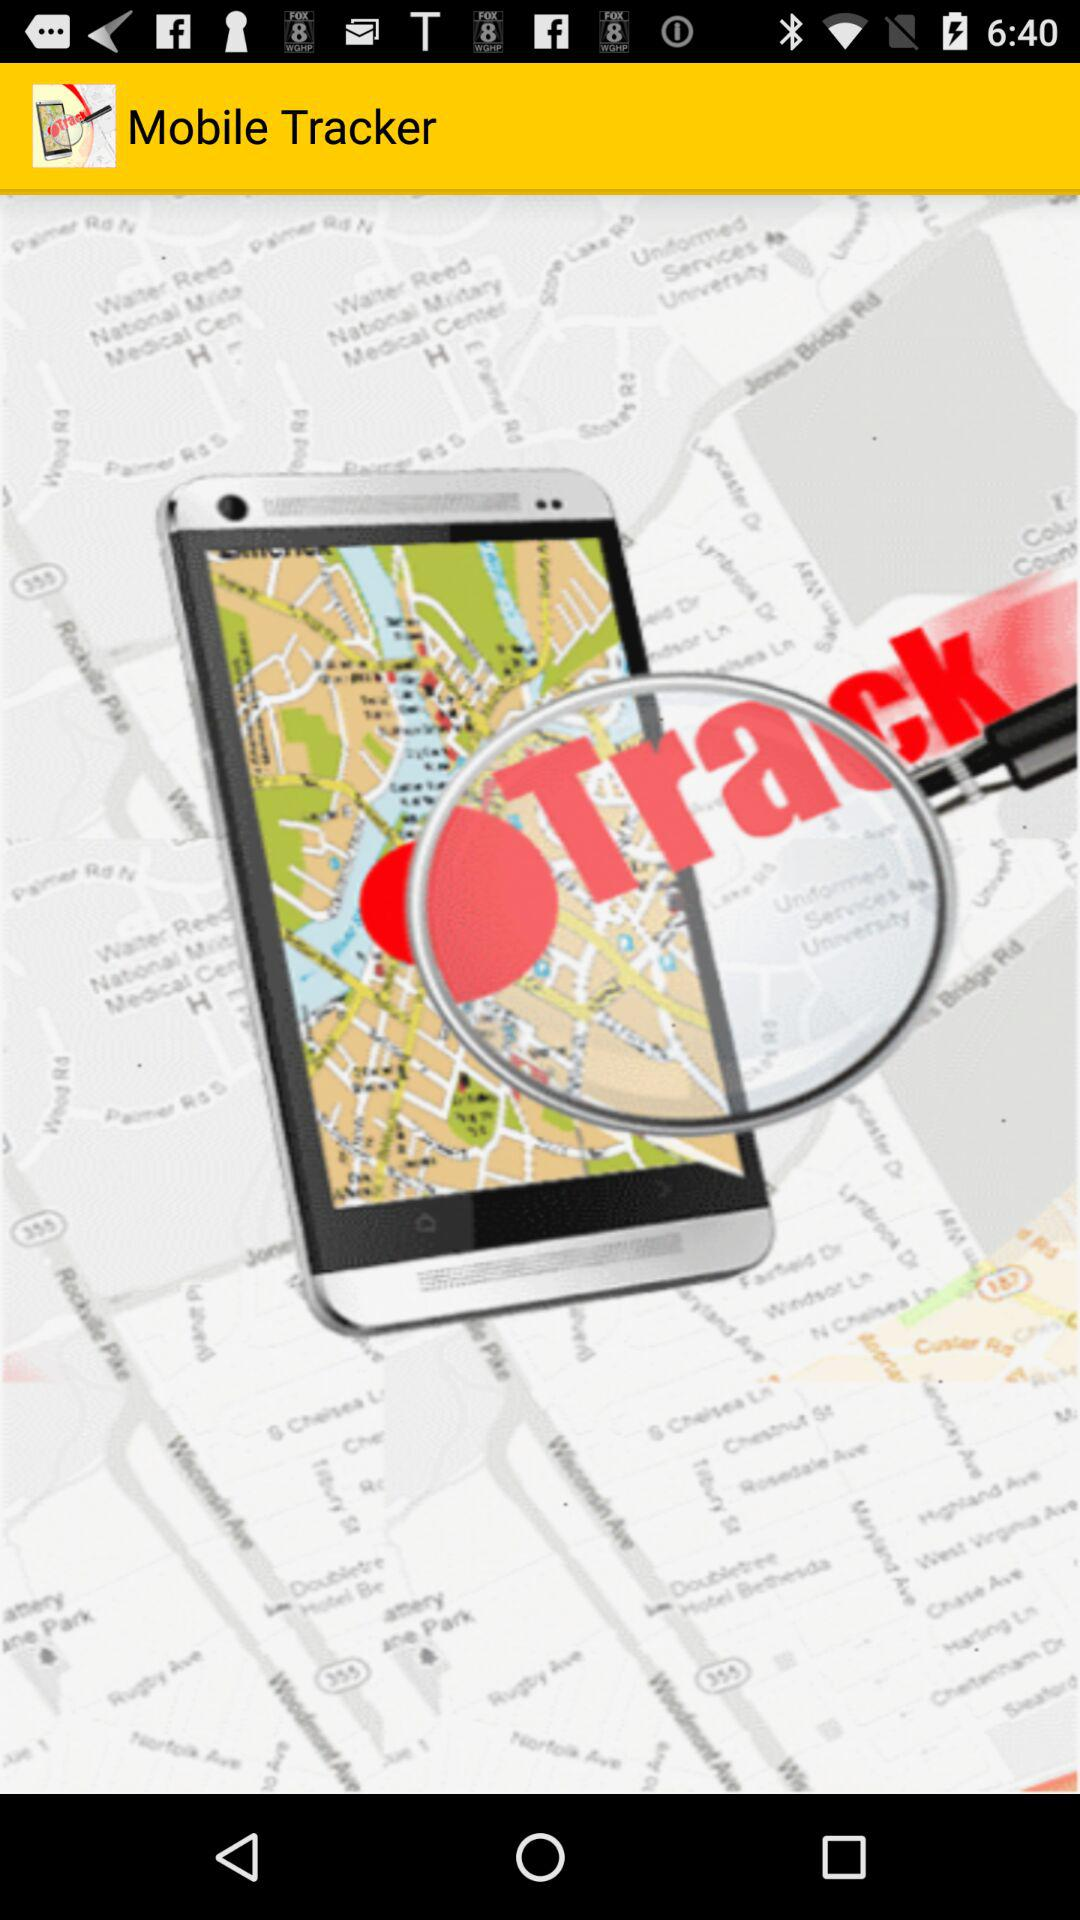What is the name of the application? The name of the application is "Mobile Tracker". 